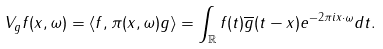Convert formula to latex. <formula><loc_0><loc_0><loc_500><loc_500>V _ { g } f ( x , \omega ) = \langle f , \pi ( x , \omega ) g \rangle = \int _ { \mathbb { R } } f ( t ) \overline { g } ( t - x ) e ^ { - 2 \pi i x \cdot \omega } d t .</formula> 